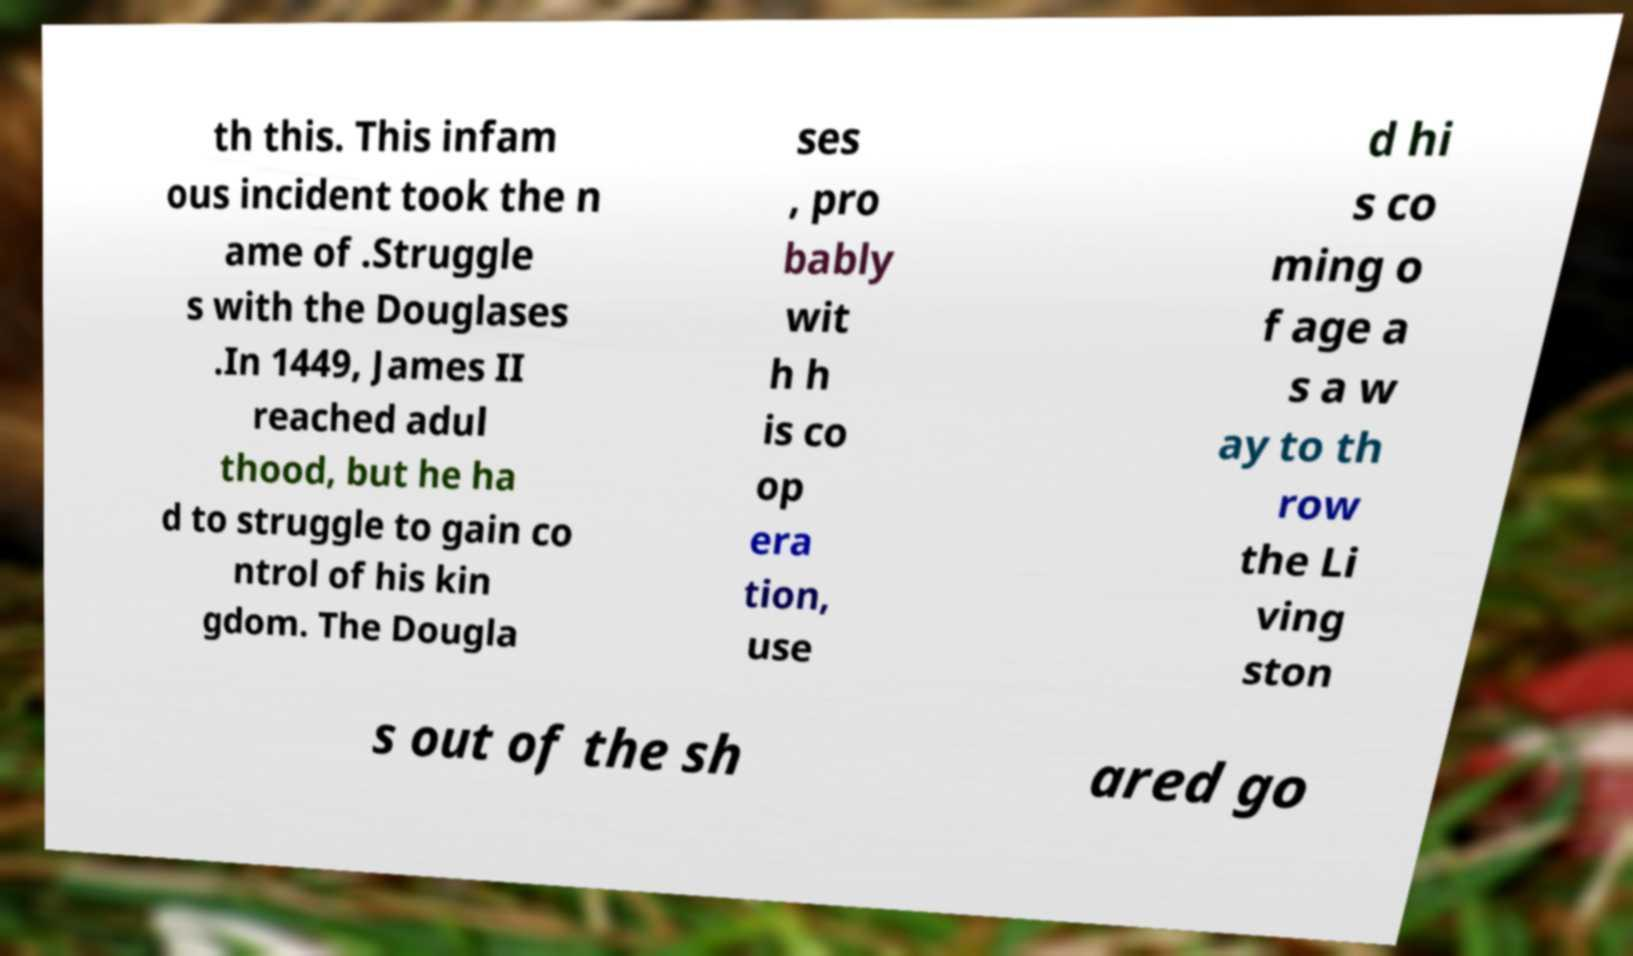Please identify and transcribe the text found in this image. th this. This infam ous incident took the n ame of .Struggle s with the Douglases .In 1449, James II reached adul thood, but he ha d to struggle to gain co ntrol of his kin gdom. The Dougla ses , pro bably wit h h is co op era tion, use d hi s co ming o f age a s a w ay to th row the Li ving ston s out of the sh ared go 